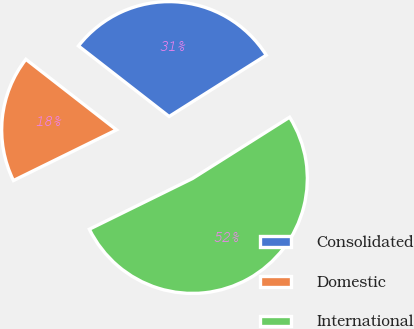Convert chart. <chart><loc_0><loc_0><loc_500><loc_500><pie_chart><fcel>Consolidated<fcel>Domestic<fcel>International<nl><fcel>30.51%<fcel>17.8%<fcel>51.69%<nl></chart> 